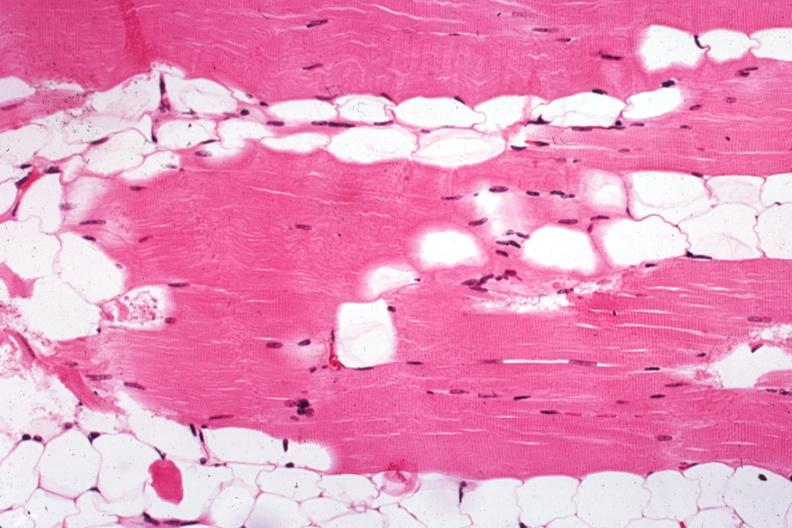s endometritis postpartum present?
Answer the question using a single word or phrase. No 